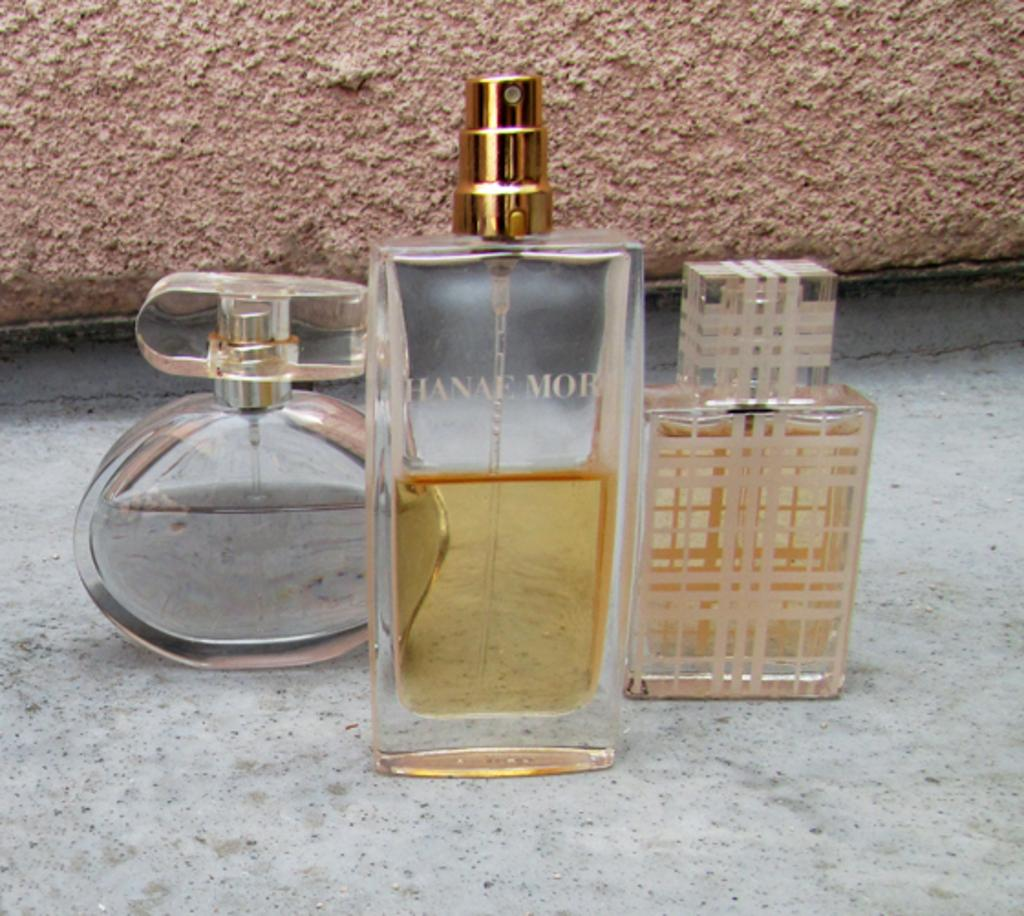What objects are present in the image? There are perfume bottles in the image. What can be seen in the background of the image? There is a wall in the background of the image. How many tomatoes can be seen in the image? There are no tomatoes present in the image. What type of drawer is visible in the image? There is no drawer visible in the image. 